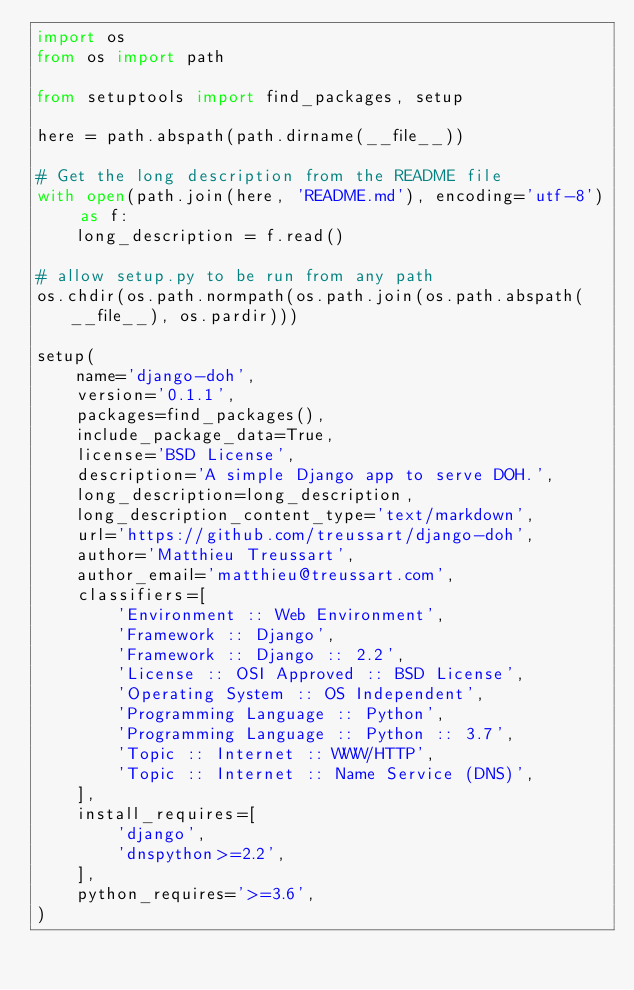<code> <loc_0><loc_0><loc_500><loc_500><_Python_>import os
from os import path

from setuptools import find_packages, setup

here = path.abspath(path.dirname(__file__))

# Get the long description from the README file
with open(path.join(here, 'README.md'), encoding='utf-8') as f:
    long_description = f.read()

# allow setup.py to be run from any path
os.chdir(os.path.normpath(os.path.join(os.path.abspath(__file__), os.pardir)))

setup(
    name='django-doh',
    version='0.1.1',
    packages=find_packages(),
    include_package_data=True,
    license='BSD License',
    description='A simple Django app to serve DOH.',
    long_description=long_description,
    long_description_content_type='text/markdown',
    url='https://github.com/treussart/django-doh',
    author='Matthieu Treussart',
    author_email='matthieu@treussart.com',
    classifiers=[
        'Environment :: Web Environment',
        'Framework :: Django',
        'Framework :: Django :: 2.2',
        'License :: OSI Approved :: BSD License',
        'Operating System :: OS Independent',
        'Programming Language :: Python',
        'Programming Language :: Python :: 3.7',
        'Topic :: Internet :: WWW/HTTP',
        'Topic :: Internet :: Name Service (DNS)',
    ],
    install_requires=[
        'django',
        'dnspython>=2.2',
    ],
    python_requires='>=3.6',
)
</code> 